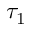<formula> <loc_0><loc_0><loc_500><loc_500>\tau _ { 1 }</formula> 